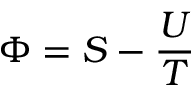Convert formula to latex. <formula><loc_0><loc_0><loc_500><loc_500>\Phi = S - { \frac { U } { T } }</formula> 